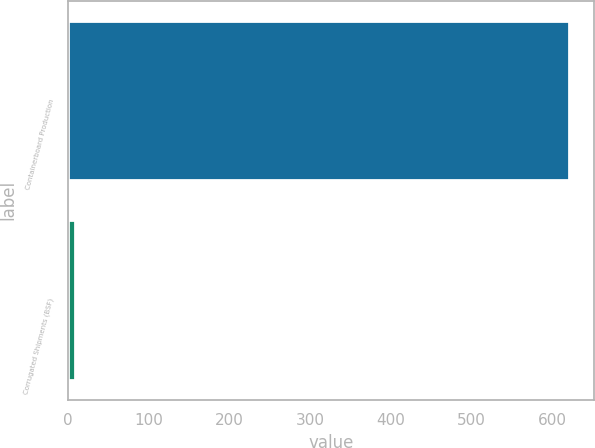Convert chart to OTSL. <chart><loc_0><loc_0><loc_500><loc_500><bar_chart><fcel>Containerboard Production<fcel>Corrugated Shipments (BSF)<nl><fcel>621<fcel>7.8<nl></chart> 